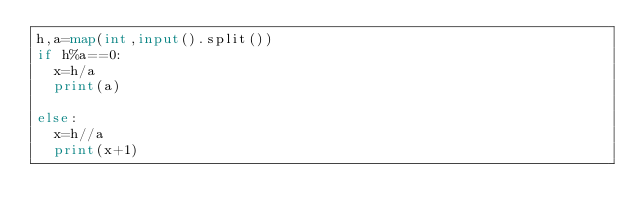Convert code to text. <code><loc_0><loc_0><loc_500><loc_500><_Python_>h,a=map(int,input().split())
if h%a==0:
  x=h/a
  print(a)

else:
  x=h//a
  print(x+1)
</code> 